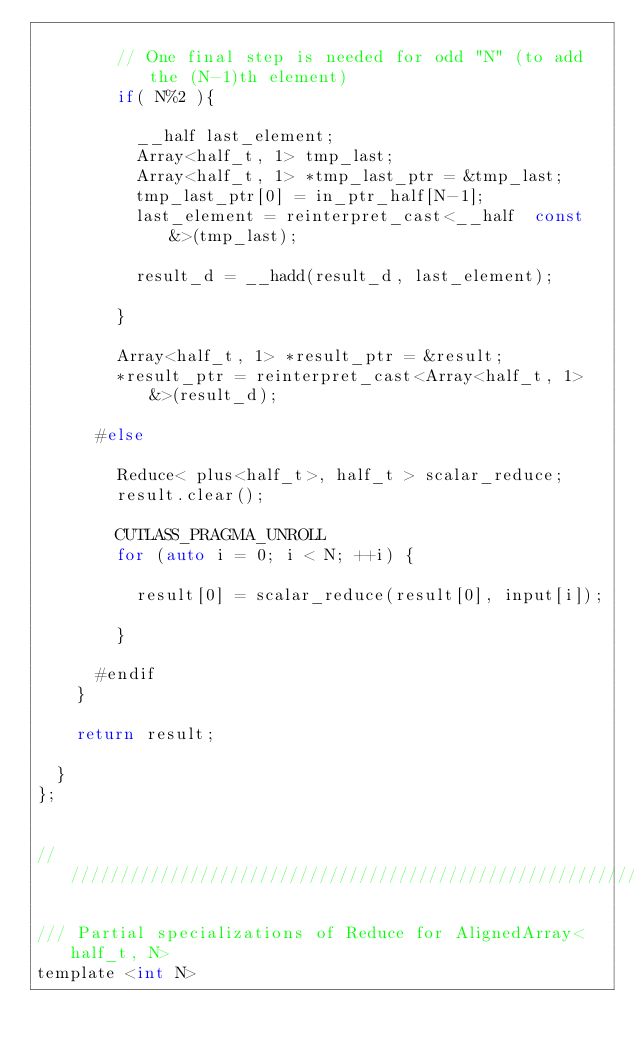Convert code to text. <code><loc_0><loc_0><loc_500><loc_500><_C_>    
        // One final step is needed for odd "N" (to add the (N-1)th element)
        if( N%2 ){

          __half last_element;
          Array<half_t, 1> tmp_last;
          Array<half_t, 1> *tmp_last_ptr = &tmp_last;
          tmp_last_ptr[0] = in_ptr_half[N-1];
          last_element = reinterpret_cast<__half  const &>(tmp_last);

          result_d = __hadd(result_d, last_element);

        } 

        Array<half_t, 1> *result_ptr = &result;
        *result_ptr = reinterpret_cast<Array<half_t, 1> &>(result_d);

      #else
        
        Reduce< plus<half_t>, half_t > scalar_reduce;
        result.clear();

        CUTLASS_PRAGMA_UNROLL
        for (auto i = 0; i < N; ++i) {

          result[0] = scalar_reduce(result[0], input[i]);

        }

      #endif
    }

    return result;
      
  }
};


/////////////////////////////////////////////////////////////////////////////////////////////////

/// Partial specializations of Reduce for AlignedArray<half_t, N>
template <int N></code> 